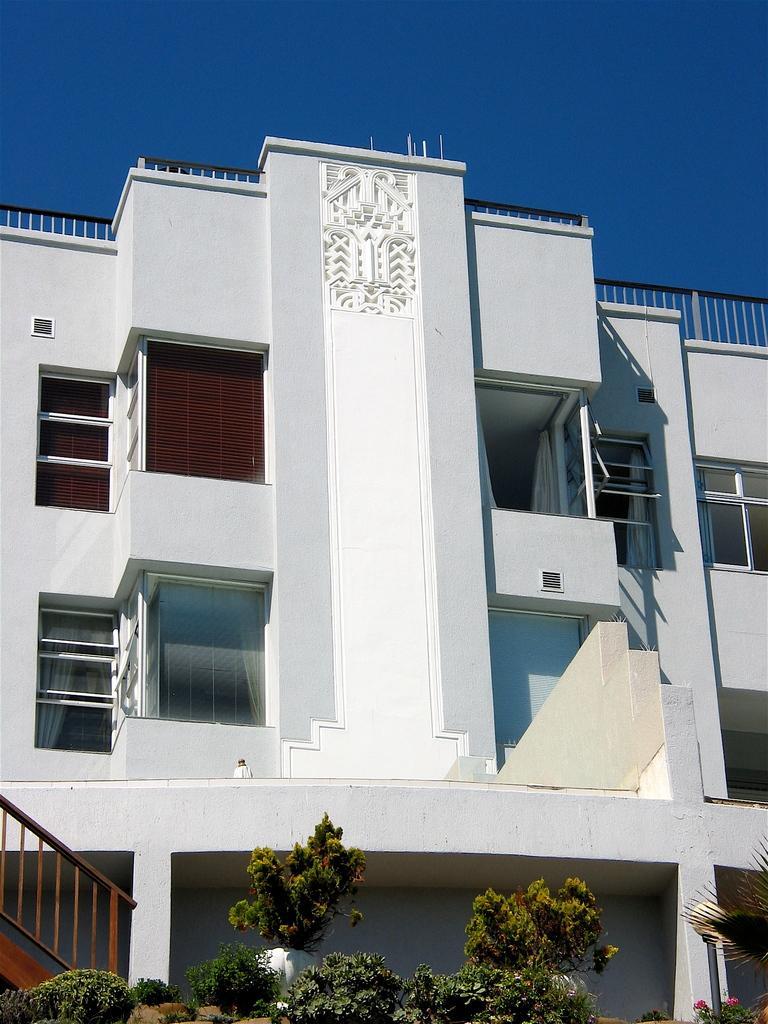Describe this image in one or two sentences. In this image in the front there are plants and in the background there is a building which is white in colour. In front of the building on the left side there is a staircase. 